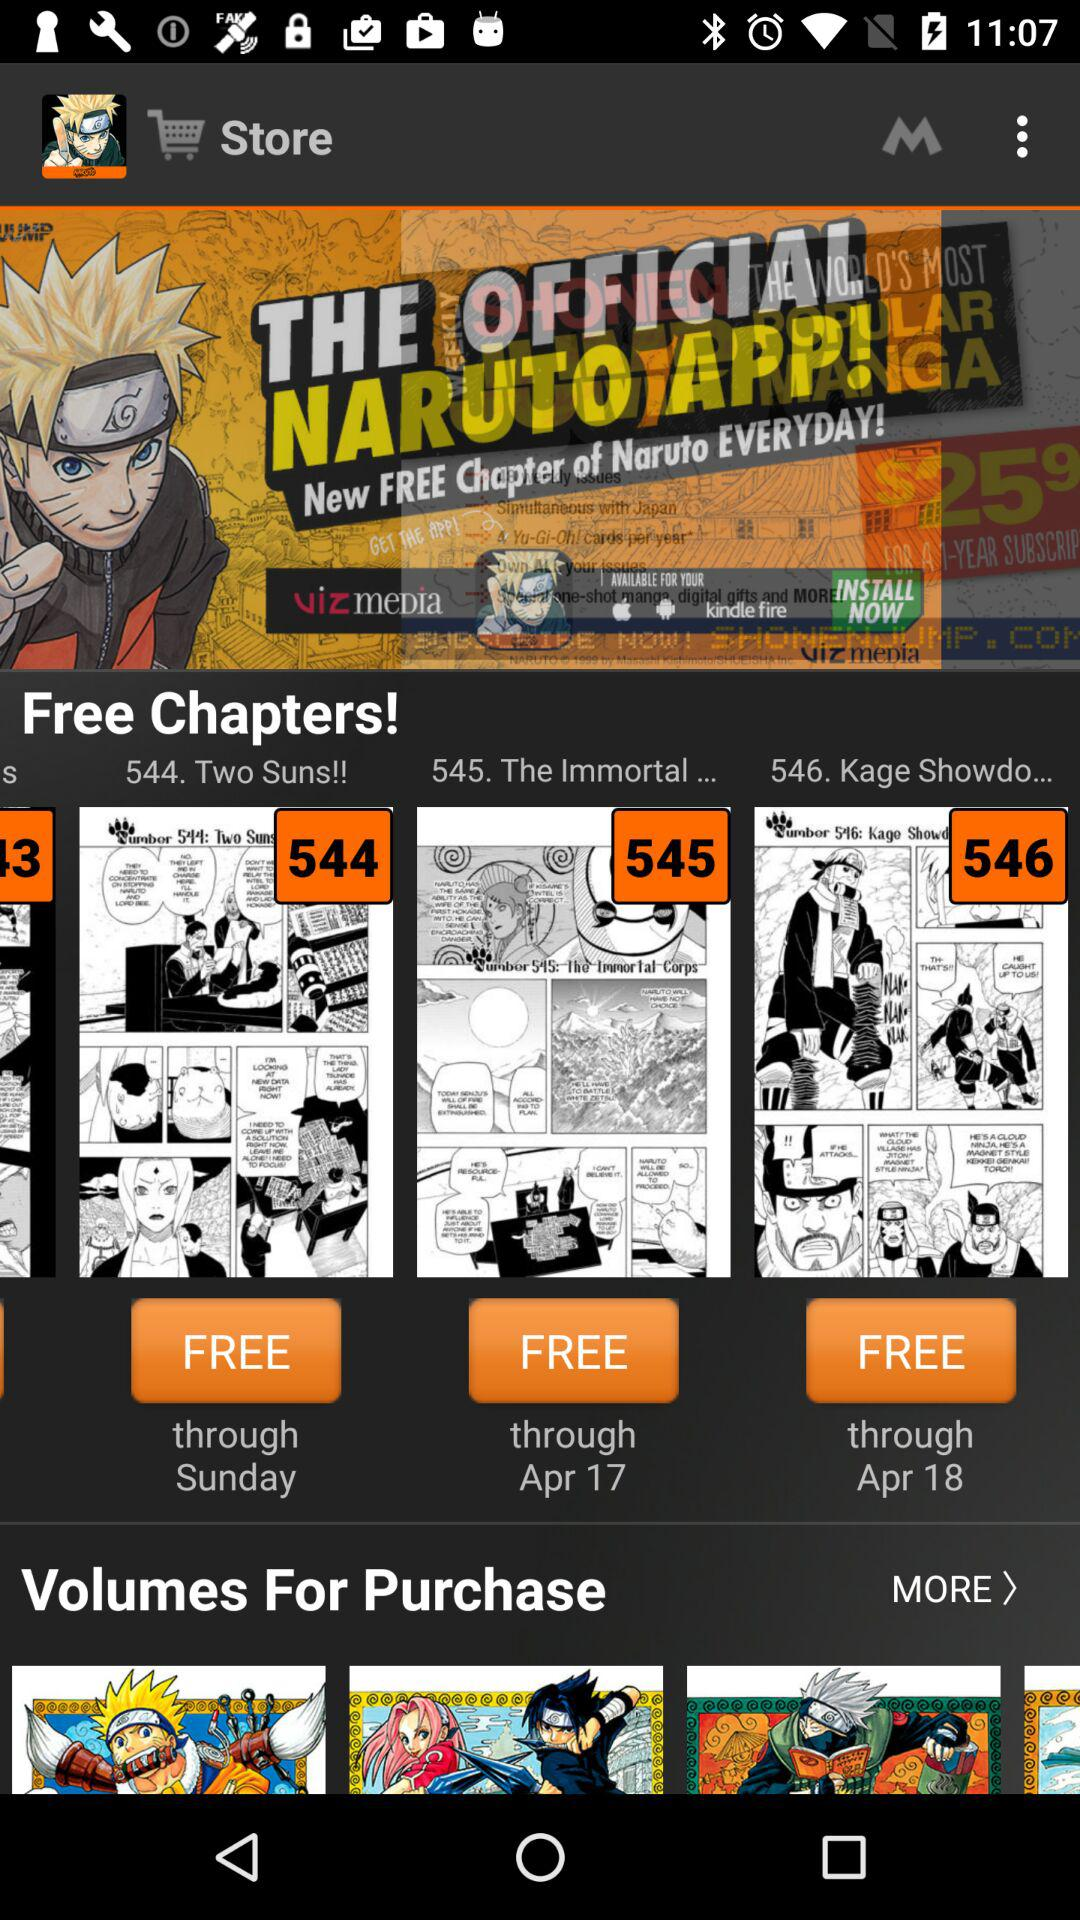How many items are in the cart?
When the provided information is insufficient, respond with <no answer>. <no answer> 